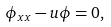Convert formula to latex. <formula><loc_0><loc_0><loc_500><loc_500>\phi _ { x x } - u \phi = 0 ,</formula> 